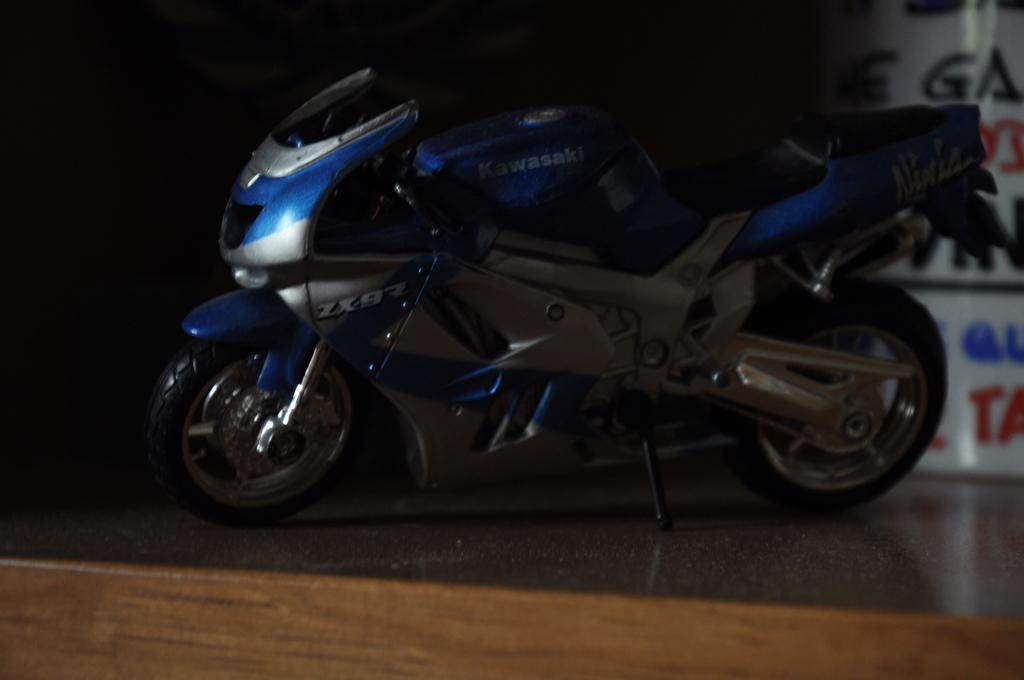Can you describe this image briefly? In this image there is a bike on the floor. Right side there is a board having some text. 